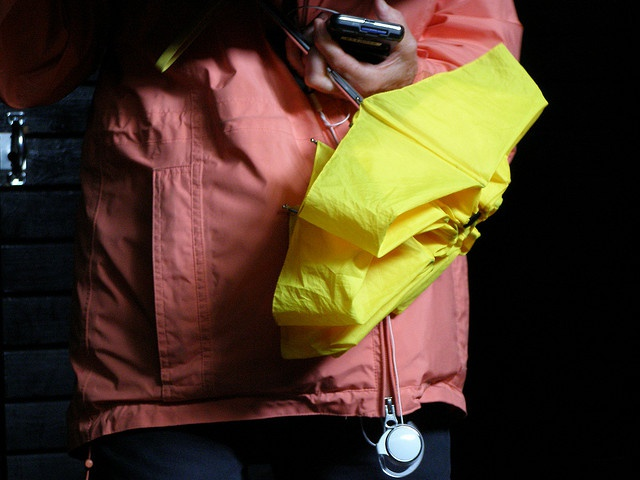Describe the objects in this image and their specific colors. I can see people in black, maroon, brown, and salmon tones, umbrella in black, khaki, and olive tones, and cell phone in black, white, gray, and blue tones in this image. 